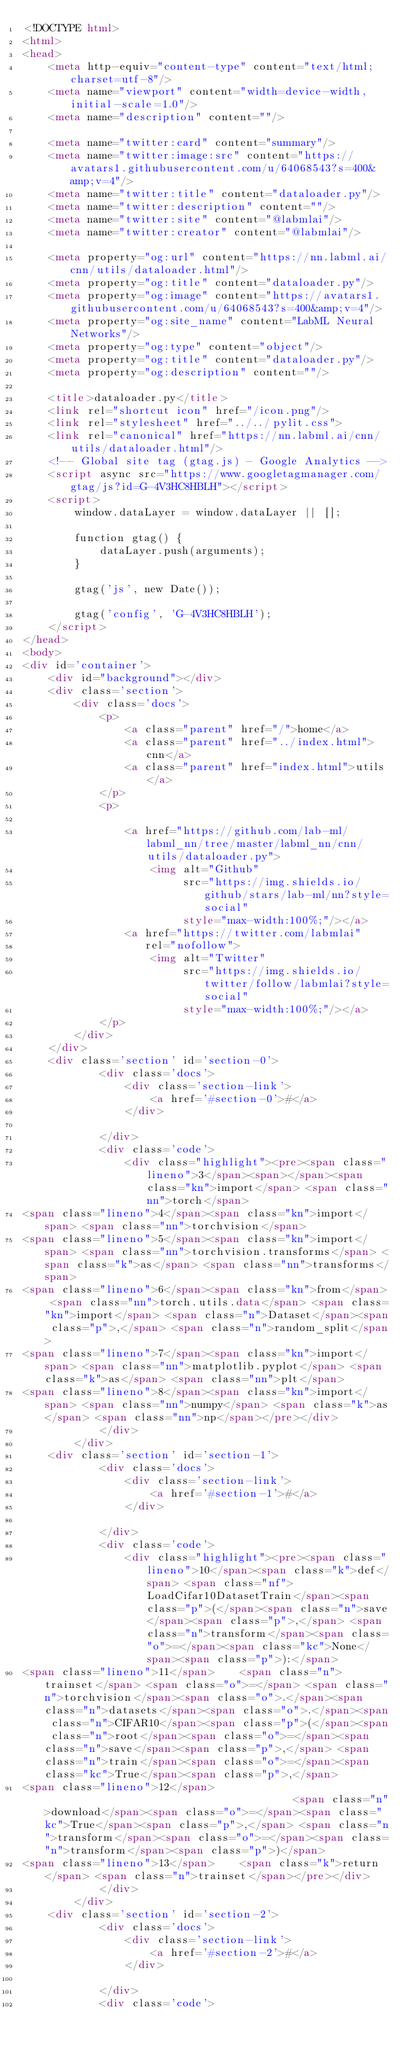Convert code to text. <code><loc_0><loc_0><loc_500><loc_500><_HTML_><!DOCTYPE html>
<html>
<head>
    <meta http-equiv="content-type" content="text/html;charset=utf-8"/>
    <meta name="viewport" content="width=device-width, initial-scale=1.0"/>
    <meta name="description" content=""/>

    <meta name="twitter:card" content="summary"/>
    <meta name="twitter:image:src" content="https://avatars1.githubusercontent.com/u/64068543?s=400&amp;v=4"/>
    <meta name="twitter:title" content="dataloader.py"/>
    <meta name="twitter:description" content=""/>
    <meta name="twitter:site" content="@labmlai"/>
    <meta name="twitter:creator" content="@labmlai"/>

    <meta property="og:url" content="https://nn.labml.ai/cnn/utils/dataloader.html"/>
    <meta property="og:title" content="dataloader.py"/>
    <meta property="og:image" content="https://avatars1.githubusercontent.com/u/64068543?s=400&amp;v=4"/>
    <meta property="og:site_name" content="LabML Neural Networks"/>
    <meta property="og:type" content="object"/>
    <meta property="og:title" content="dataloader.py"/>
    <meta property="og:description" content=""/>

    <title>dataloader.py</title>
    <link rel="shortcut icon" href="/icon.png"/>
    <link rel="stylesheet" href="../../pylit.css">
    <link rel="canonical" href="https://nn.labml.ai/cnn/utils/dataloader.html"/>
    <!-- Global site tag (gtag.js) - Google Analytics -->
    <script async src="https://www.googletagmanager.com/gtag/js?id=G-4V3HC8HBLH"></script>
    <script>
        window.dataLayer = window.dataLayer || [];

        function gtag() {
            dataLayer.push(arguments);
        }

        gtag('js', new Date());

        gtag('config', 'G-4V3HC8HBLH');
    </script>
</head>
<body>
<div id='container'>
    <div id="background"></div>
    <div class='section'>
        <div class='docs'>
            <p>
                <a class="parent" href="/">home</a>
                <a class="parent" href="../index.html">cnn</a>
                <a class="parent" href="index.html">utils</a>
            </p>
            <p>

                <a href="https://github.com/lab-ml/labml_nn/tree/master/labml_nn/cnn/utils/dataloader.py">
                    <img alt="Github"
                         src="https://img.shields.io/github/stars/lab-ml/nn?style=social"
                         style="max-width:100%;"/></a>
                <a href="https://twitter.com/labmlai"
                   rel="nofollow">
                    <img alt="Twitter"
                         src="https://img.shields.io/twitter/follow/labmlai?style=social"
                         style="max-width:100%;"/></a>
            </p>
        </div>
    </div>
    <div class='section' id='section-0'>
            <div class='docs'>
                <div class='section-link'>
                    <a href='#section-0'>#</a>
                </div>
                
            </div>
            <div class='code'>
                <div class="highlight"><pre><span class="lineno">3</span><span></span><span class="kn">import</span> <span class="nn">torch</span>
<span class="lineno">4</span><span class="kn">import</span> <span class="nn">torchvision</span>
<span class="lineno">5</span><span class="kn">import</span> <span class="nn">torchvision.transforms</span> <span class="k">as</span> <span class="nn">transforms</span>
<span class="lineno">6</span><span class="kn">from</span> <span class="nn">torch.utils.data</span> <span class="kn">import</span> <span class="n">Dataset</span><span class="p">,</span> <span class="n">random_split</span>
<span class="lineno">7</span><span class="kn">import</span> <span class="nn">matplotlib.pyplot</span> <span class="k">as</span> <span class="nn">plt</span>
<span class="lineno">8</span><span class="kn">import</span> <span class="nn">numpy</span> <span class="k">as</span> <span class="nn">np</span></pre></div>
            </div>
        </div>
    <div class='section' id='section-1'>
            <div class='docs'>
                <div class='section-link'>
                    <a href='#section-1'>#</a>
                </div>
                
            </div>
            <div class='code'>
                <div class="highlight"><pre><span class="lineno">10</span><span class="k">def</span> <span class="nf">LoadCifar10DatasetTrain</span><span class="p">(</span><span class="n">save</span><span class="p">,</span> <span class="n">transform</span><span class="o">=</span><span class="kc">None</span><span class="p">):</span>
<span class="lineno">11</span>    <span class="n">trainset</span> <span class="o">=</span> <span class="n">torchvision</span><span class="o">.</span><span class="n">datasets</span><span class="o">.</span><span class="n">CIFAR10</span><span class="p">(</span><span class="n">root</span><span class="o">=</span><span class="n">save</span><span class="p">,</span> <span class="n">train</span><span class="o">=</span><span class="kc">True</span><span class="p">,</span>
<span class="lineno">12</span>                                        <span class="n">download</span><span class="o">=</span><span class="kc">True</span><span class="p">,</span> <span class="n">transform</span><span class="o">=</span><span class="n">transform</span><span class="p">)</span>
<span class="lineno">13</span>    <span class="k">return</span> <span class="n">trainset</span></pre></div>
            </div>
        </div>
    <div class='section' id='section-2'>
            <div class='docs'>
                <div class='section-link'>
                    <a href='#section-2'>#</a>
                </div>
                
            </div>
            <div class='code'></code> 